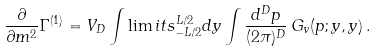Convert formula to latex. <formula><loc_0><loc_0><loc_500><loc_500>\frac { \partial } { \partial m ^ { 2 } } \Gamma ^ { ( 1 ) } = V _ { D } \int \lim i t s _ { - L / 2 } ^ { L / 2 } d y \int \frac { d ^ { D } p } { ( 2 \pi ) ^ { D } } \, G _ { v } ( p ; y , y ) \, .</formula> 